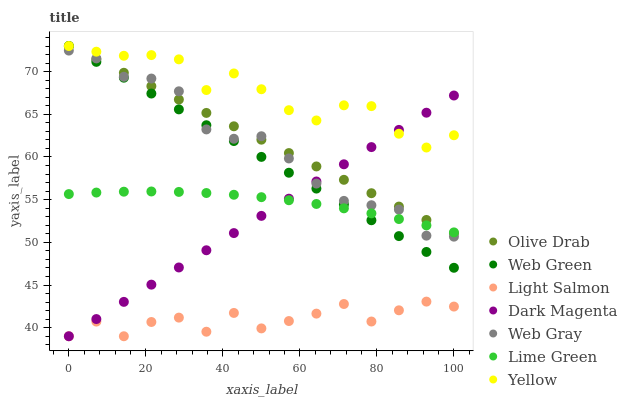Does Light Salmon have the minimum area under the curve?
Answer yes or no. Yes. Does Yellow have the maximum area under the curve?
Answer yes or no. Yes. Does Web Gray have the minimum area under the curve?
Answer yes or no. No. Does Web Gray have the maximum area under the curve?
Answer yes or no. No. Is Web Green the smoothest?
Answer yes or no. Yes. Is Light Salmon the roughest?
Answer yes or no. Yes. Is Web Gray the smoothest?
Answer yes or no. No. Is Web Gray the roughest?
Answer yes or no. No. Does Light Salmon have the lowest value?
Answer yes or no. Yes. Does Web Gray have the lowest value?
Answer yes or no. No. Does Olive Drab have the highest value?
Answer yes or no. Yes. Does Web Gray have the highest value?
Answer yes or no. No. Is Light Salmon less than Web Green?
Answer yes or no. Yes. Is Lime Green greater than Light Salmon?
Answer yes or no. Yes. Does Web Green intersect Web Gray?
Answer yes or no. Yes. Is Web Green less than Web Gray?
Answer yes or no. No. Is Web Green greater than Web Gray?
Answer yes or no. No. Does Light Salmon intersect Web Green?
Answer yes or no. No. 